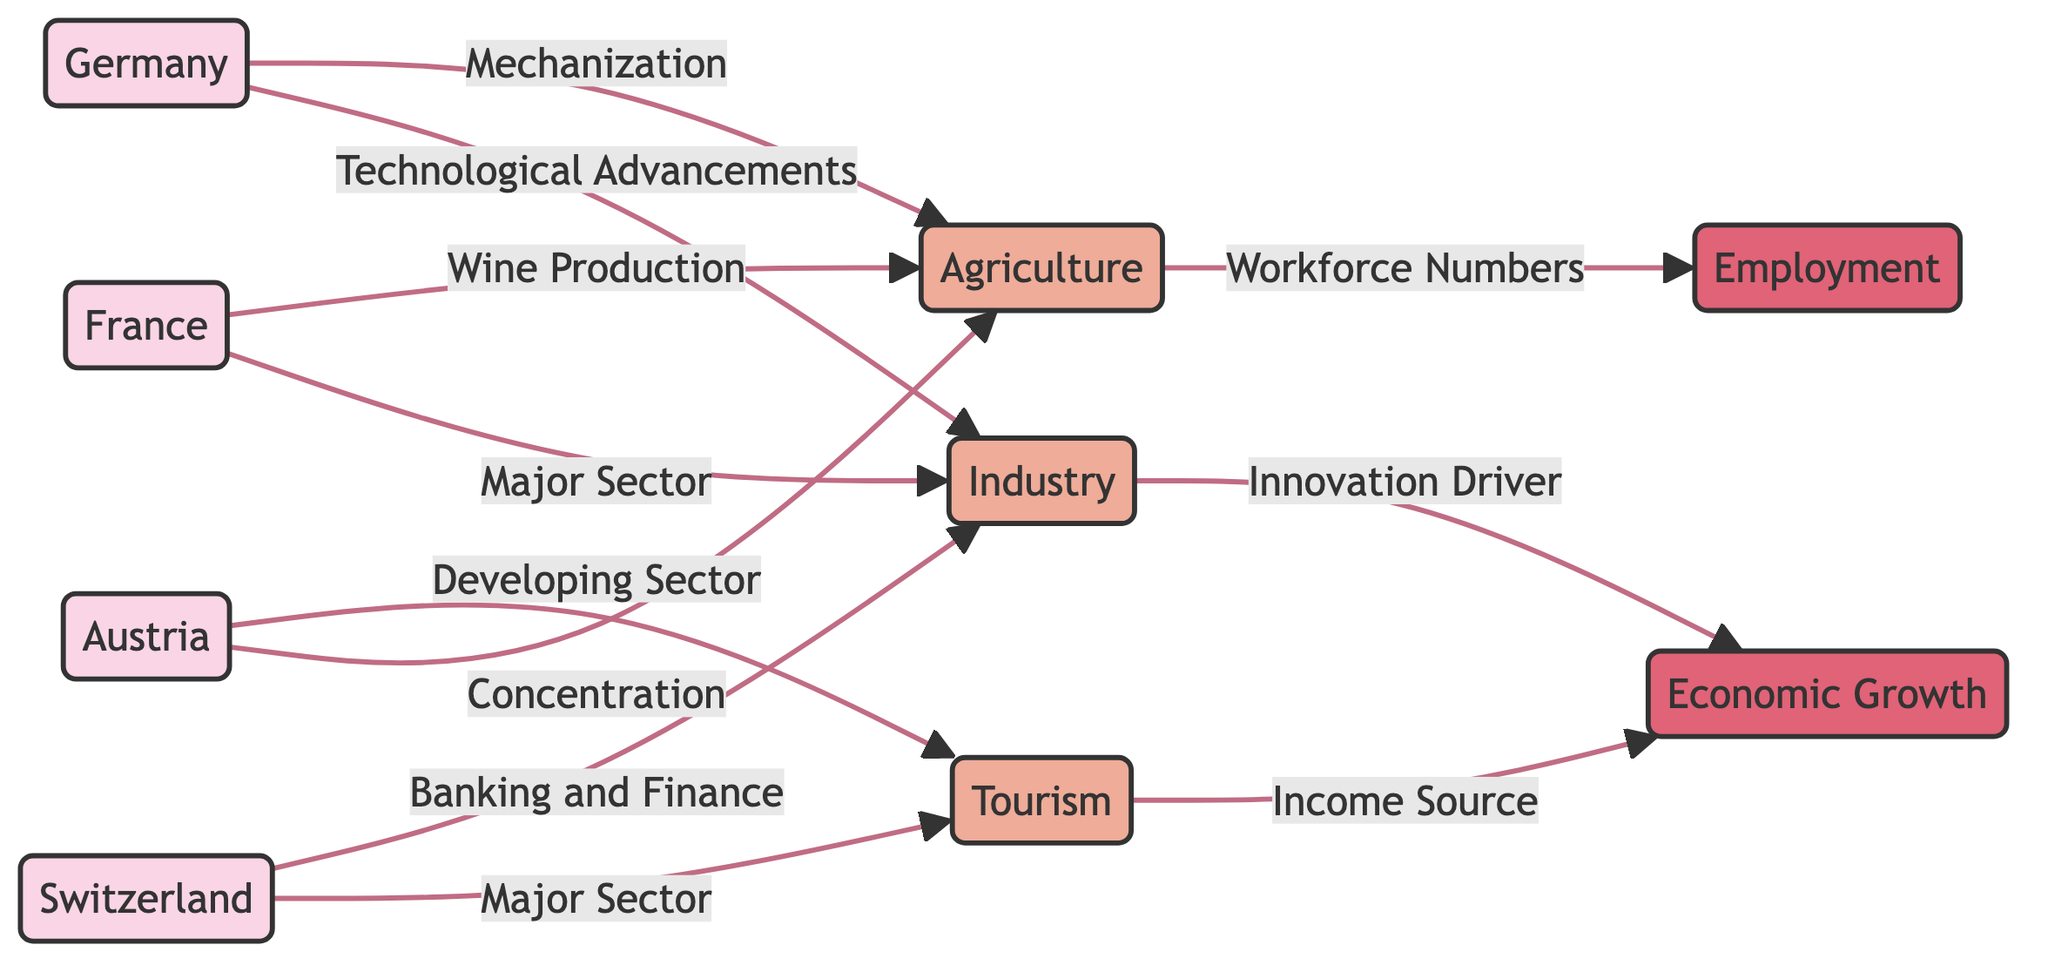How many countries are displayed in the diagram? The diagram lists four countries: Austria, Switzerland, France, and Germany. Since those are the only named nodes representing countries in the diagram, the total count is four.
Answer: 4 